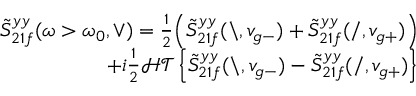Convert formula to latex. <formula><loc_0><loc_0><loc_500><loc_500>\begin{array} { r } { \tilde { S } _ { 2 1 f } ^ { y y } ( \omega > \omega _ { 0 } , \vee ) = \frac { 1 } { 2 } \left ( \tilde { S } _ { 2 1 f } ^ { y y } ( \ , v _ { g - } ) + \tilde { S } _ { 2 1 f } ^ { y y } ( / , v _ { g + } ) \right ) } \\ { + i \frac { 1 } { 2 } \mathcal { H T } \left \{ \tilde { S } _ { 2 1 f } ^ { y y } ( \ , v _ { g - } ) - \tilde { S } _ { 2 1 f } ^ { y y } ( / , v _ { g + } ) \right \} } \end{array}</formula> 